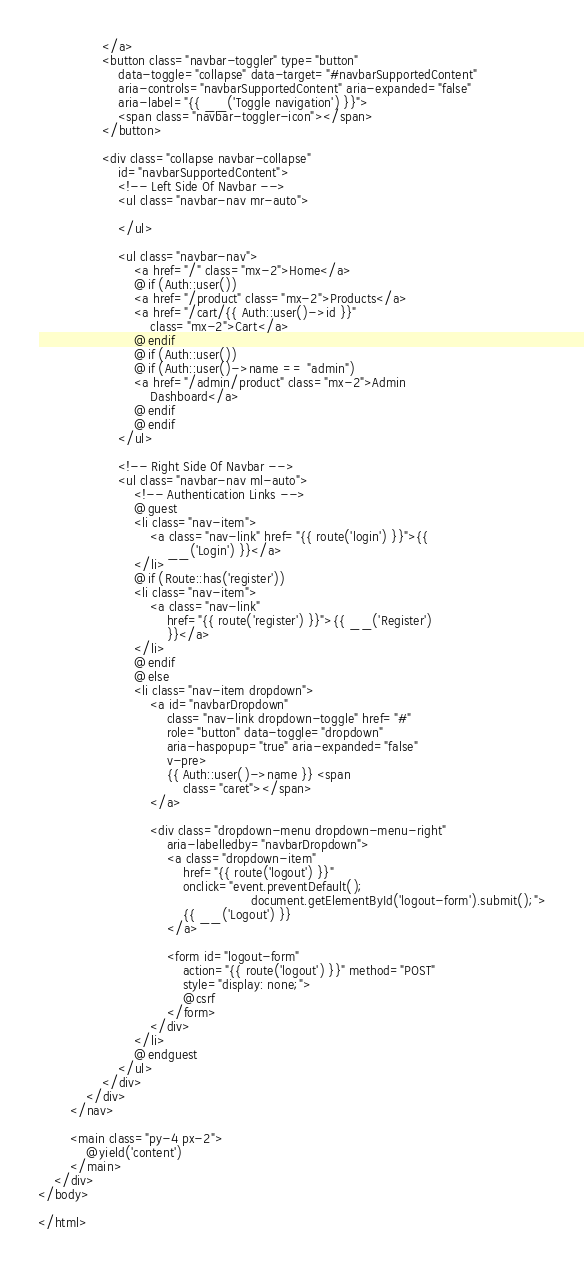<code> <loc_0><loc_0><loc_500><loc_500><_PHP_>                </a>
                <button class="navbar-toggler" type="button"
                    data-toggle="collapse" data-target="#navbarSupportedContent"
                    aria-controls="navbarSupportedContent" aria-expanded="false"
                    aria-label="{{ __('Toggle navigation') }}">
                    <span class="navbar-toggler-icon"></span>
                </button>

                <div class="collapse navbar-collapse"
                    id="navbarSupportedContent">
                    <!-- Left Side Of Navbar -->
                    <ul class="navbar-nav mr-auto">

                    </ul>

                    <ul class="navbar-nav">
                        <a href="/" class="mx-2">Home</a>
                        @if (Auth::user())
                        <a href="/product" class="mx-2">Products</a>
                        <a href="/cart/{{ Auth::user()->id }}"
                            class="mx-2">Cart</a>
                        @endif
                        @if (Auth::user())
                        @if (Auth::user()->name == "admin")
                        <a href="/admin/product" class="mx-2">Admin
                            Dashboard</a>
                        @endif
                        @endif
                    </ul>

                    <!-- Right Side Of Navbar -->
                    <ul class="navbar-nav ml-auto">
                        <!-- Authentication Links -->
                        @guest
                        <li class="nav-item">
                            <a class="nav-link" href="{{ route('login') }}">{{
                                __('Login') }}</a>
                        </li>
                        @if (Route::has('register'))
                        <li class="nav-item">
                            <a class="nav-link"
                                href="{{ route('register') }}">{{ __('Register')
                                }}</a>
                        </li>
                        @endif
                        @else
                        <li class="nav-item dropdown">
                            <a id="navbarDropdown"
                                class="nav-link dropdown-toggle" href="#"
                                role="button" data-toggle="dropdown"
                                aria-haspopup="true" aria-expanded="false"
                                v-pre>
                                {{ Auth::user()->name }} <span
                                    class="caret"></span>
                            </a>

                            <div class="dropdown-menu dropdown-menu-right"
                                aria-labelledby="navbarDropdown">
                                <a class="dropdown-item"
                                    href="{{ route('logout') }}"
                                    onclick="event.preventDefault();
                                                     document.getElementById('logout-form').submit();">
                                    {{ __('Logout') }}
                                </a>

                                <form id="logout-form"
                                    action="{{ route('logout') }}" method="POST"
                                    style="display: none;">
                                    @csrf
                                </form>
                            </div>
                        </li>
                        @endguest
                    </ul>
                </div>
            </div>
        </nav>

        <main class="py-4 px-2">
            @yield('content')
        </main>
    </div>
</body>

</html></code> 